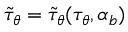<formula> <loc_0><loc_0><loc_500><loc_500>\tilde { \tau } _ { \theta } = \tilde { \tau } _ { \theta } ( \tau _ { \theta } , \alpha _ { b } )</formula> 